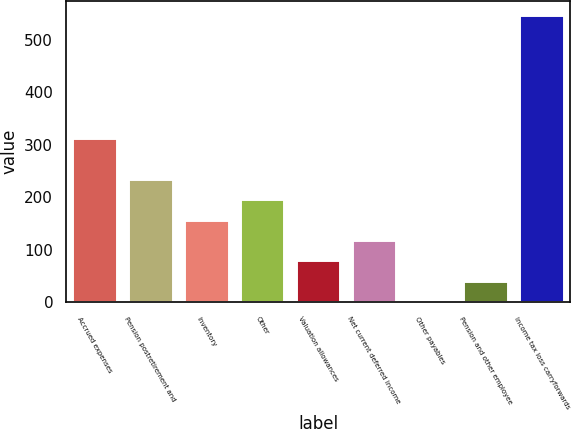Convert chart. <chart><loc_0><loc_0><loc_500><loc_500><bar_chart><fcel>Accrued expenses<fcel>Pension postretirement and<fcel>Inventory<fcel>Other<fcel>Valuation allowances<fcel>Net current deferred income<fcel>Other payables<fcel>Pension and other employee<fcel>Income tax loss carryforwards<nl><fcel>313.36<fcel>235.62<fcel>157.88<fcel>196.75<fcel>80.14<fcel>119.01<fcel>2.4<fcel>41.27<fcel>546.58<nl></chart> 